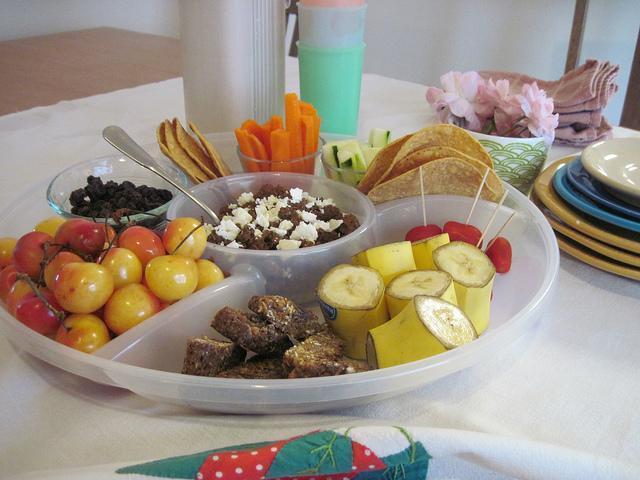How many bowls are there?
Give a very brief answer. 3. How many dining tables can you see?
Give a very brief answer. 2. How many bananas are in the photo?
Give a very brief answer. 3. How many cups are visible?
Give a very brief answer. 2. How many orange signs are there?
Give a very brief answer. 0. 